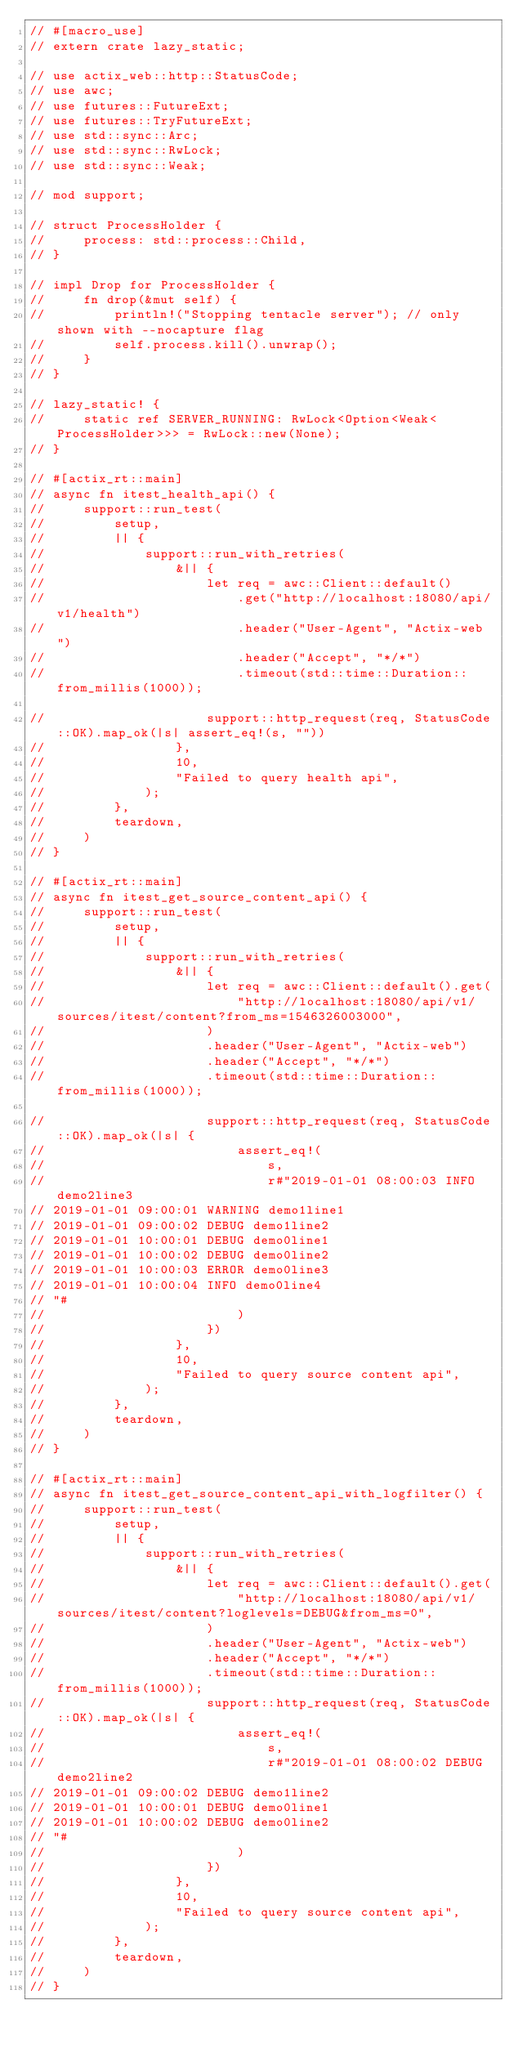Convert code to text. <code><loc_0><loc_0><loc_500><loc_500><_Rust_>// #[macro_use]
// extern crate lazy_static;

// use actix_web::http::StatusCode;
// use awc;
// use futures::FutureExt;
// use futures::TryFutureExt;
// use std::sync::Arc;
// use std::sync::RwLock;
// use std::sync::Weak;

// mod support;

// struct ProcessHolder {
//     process: std::process::Child,
// }

// impl Drop for ProcessHolder {
//     fn drop(&mut self) {
//         println!("Stopping tentacle server"); // only shown with --nocapture flag
//         self.process.kill().unwrap();
//     }
// }

// lazy_static! {
//     static ref SERVER_RUNNING: RwLock<Option<Weak<ProcessHolder>>> = RwLock::new(None);
// }

// #[actix_rt::main]
// async fn itest_health_api() {
//     support::run_test(
//         setup,
//         || {
//             support::run_with_retries(
//                 &|| {
//                     let req = awc::Client::default()
//                         .get("http://localhost:18080/api/v1/health")
//                         .header("User-Agent", "Actix-web")
//                         .header("Accept", "*/*")
//                         .timeout(std::time::Duration::from_millis(1000));

//                     support::http_request(req, StatusCode::OK).map_ok(|s| assert_eq!(s, ""))
//                 },
//                 10,
//                 "Failed to query health api",
//             );
//         },
//         teardown,
//     )
// }

// #[actix_rt::main]
// async fn itest_get_source_content_api() {
//     support::run_test(
//         setup,
//         || {
//             support::run_with_retries(
//                 &|| {
//                     let req = awc::Client::default().get(
//                         "http://localhost:18080/api/v1/sources/itest/content?from_ms=1546326003000",
//                     )
//                     .header("User-Agent", "Actix-web")
//                     .header("Accept", "*/*")
//                     .timeout(std::time::Duration::from_millis(1000));

//                     support::http_request(req, StatusCode::OK).map_ok(|s| {
//                         assert_eq!(
//                             s,
//                             r#"2019-01-01 08:00:03 INFO demo2line3
// 2019-01-01 09:00:01 WARNING demo1line1
// 2019-01-01 09:00:02 DEBUG demo1line2
// 2019-01-01 10:00:01 DEBUG demo0line1
// 2019-01-01 10:00:02 DEBUG demo0line2
// 2019-01-01 10:00:03 ERROR demo0line3
// 2019-01-01 10:00:04 INFO demo0line4
// "#
//                         )
//                     })
//                 },
//                 10,
//                 "Failed to query source content api",
//             );
//         },
//         teardown,
//     )
// }

// #[actix_rt::main]
// async fn itest_get_source_content_api_with_logfilter() {
//     support::run_test(
//         setup,
//         || {
//             support::run_with_retries(
//                 &|| {
//                     let req = awc::Client::default().get(
//                         "http://localhost:18080/api/v1/sources/itest/content?loglevels=DEBUG&from_ms=0",
//                     )
//                     .header("User-Agent", "Actix-web")
//                     .header("Accept", "*/*")
//                     .timeout(std::time::Duration::from_millis(1000));
//                     support::http_request(req, StatusCode::OK).map_ok(|s| {
//                         assert_eq!(
//                             s,
//                             r#"2019-01-01 08:00:02 DEBUG demo2line2
// 2019-01-01 09:00:02 DEBUG demo1line2
// 2019-01-01 10:00:01 DEBUG demo0line1
// 2019-01-01 10:00:02 DEBUG demo0line2
// "#
//                         )
//                     })
//                 },
//                 10,
//                 "Failed to query source content api",
//             );
//         },
//         teardown,
//     )
// }
</code> 